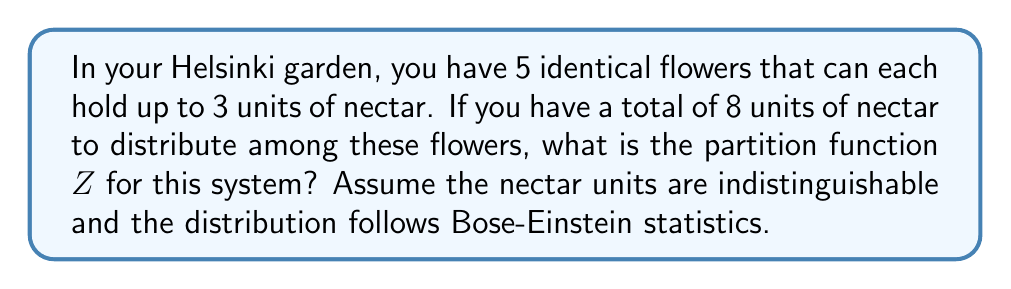Can you solve this math problem? To solve this problem, we need to follow these steps:

1) First, we need to understand that this is a problem of distributing indistinguishable particles (nectar units) into distinguishable boxes (flowers) with a maximum occupancy per box. This scenario follows Bose-Einstein statistics with an upper limit.

2) The partition function $Z$ is the sum of all possible microstates. In this case, a microstate is a specific distribution of nectar units among the flowers.

3) We can use the stars and bars method with restrictions to count the number of ways to distribute the nectar. The general formula for this is:

   $$Z = \sum_{k=0}^{min(N,M\cdot n)} \binom{N-k+M-1}{M-1} \binom{M\cdot n-k}{M-1}$$

   Where:
   $N$ = total number of nectar units (8)
   $M$ = number of flowers (5)
   $n$ = maximum number of nectar units per flower (3)

4) Plugging in our values:

   $$Z = \sum_{k=0}^{min(8,5\cdot 3)} \binom{8-k+5-1}{5-1} \binom{5\cdot 3-k}{5-1}$$

5) The upper limit of the sum is $min(8,15) = 8$

6) Now we need to calculate each term:

   For $k=0$: $\binom{12}{4} \binom{15}{4} = 495 \cdot 1365 = 675675$
   For $k=1$: $\binom{11}{4} \binom{14}{4} = 330 \cdot 1001 = 330330$
   For $k=2$: $\binom{10}{4} \binom{13}{4} = 210 \cdot 715 = 150150$
   For $k=3$: $\binom{9}{4} \binom{12}{4} = 126 \cdot 495 = 62370$
   For $k=4$: $\binom{8}{4} \binom{11}{4} = 70 \cdot 330 = 23100$
   For $k=5$: $\binom{7}{4} \binom{10}{4} = 35 \cdot 210 = 7350$
   For $k=6$: $\binom{6}{4} \binom{9}{4} = 15 \cdot 126 = 1890$
   For $k=7$: $\binom{5}{4} \binom{8}{4} = 5 \cdot 70 = 350$
   For $k=8$: $\binom{4}{4} \binom{7}{4} = 1 \cdot 35 = 35$

7) Sum all these terms:

   $Z = 675675 + 330330 + 150150 + 62370 + 23100 + 7350 + 1890 + 350 + 35 = 1251250$
Answer: $Z = 1251250$ 